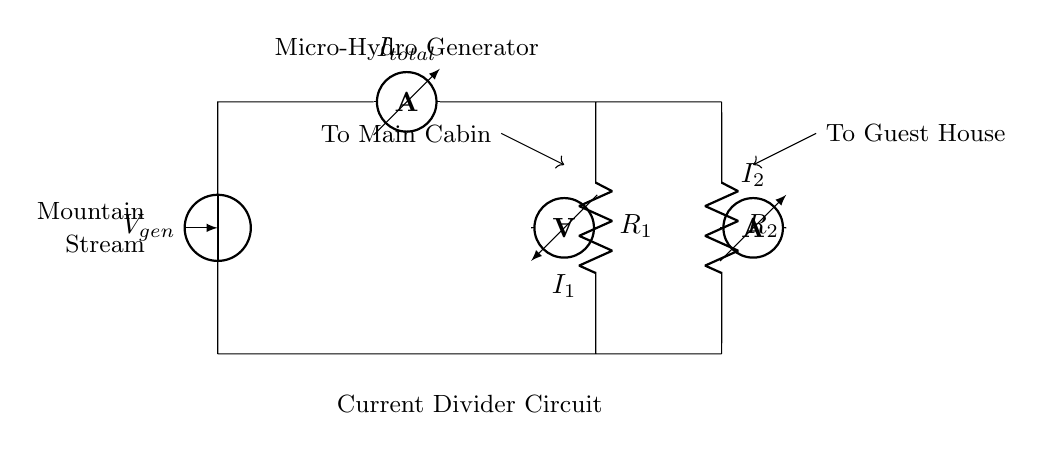What is the total current in the circuit? The total current is indicated by the ammeter labeled I_total, which measures the current flowing from the micro-hydro generator through the circuit.
Answer: I_total What are the resistances in the circuit? The circuit contains two resistors labeled R_1 and R_2, which are connected in parallel from the same voltage source.
Answer: R_1, R_2 Which component supplies power to the circuit? The component supplying power is the voltage source labeled V_gen, which represents the output voltage of the micro-hydro generator.
Answer: V_gen What do the ammeters I_1 and I_2 measure? The ammeter labeled I_1 measures the current flowing through resistor R_1, while I_2 measures the current through R_2.
Answer: I_1, I_2 How does current divide in this circuit? The current divides between the two resistors R_1 and R_2 based on their resistances; lower resistance receives more current according to the current divider principle.
Answer: By resistance values What is the main function of this circuit? The circuit functions as a current divider to distribute power from the micro-hydro generator to multiple loads, such as the main cabin and guest house.
Answer: Distribute power Where does the power from the generator go? The power flows to two locations: the main cabin and the guest house, as indicated by the arrows pointing to each destination from the ammeters.
Answer: Main cabin, guest house 